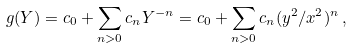<formula> <loc_0><loc_0><loc_500><loc_500>g ( Y ) = c _ { 0 } + \sum _ { n > 0 } c _ { n } Y ^ { - n } = c _ { 0 } + \sum _ { n > 0 } c _ { n } ( y ^ { 2 } / x ^ { 2 } ) ^ { n } \, ,</formula> 